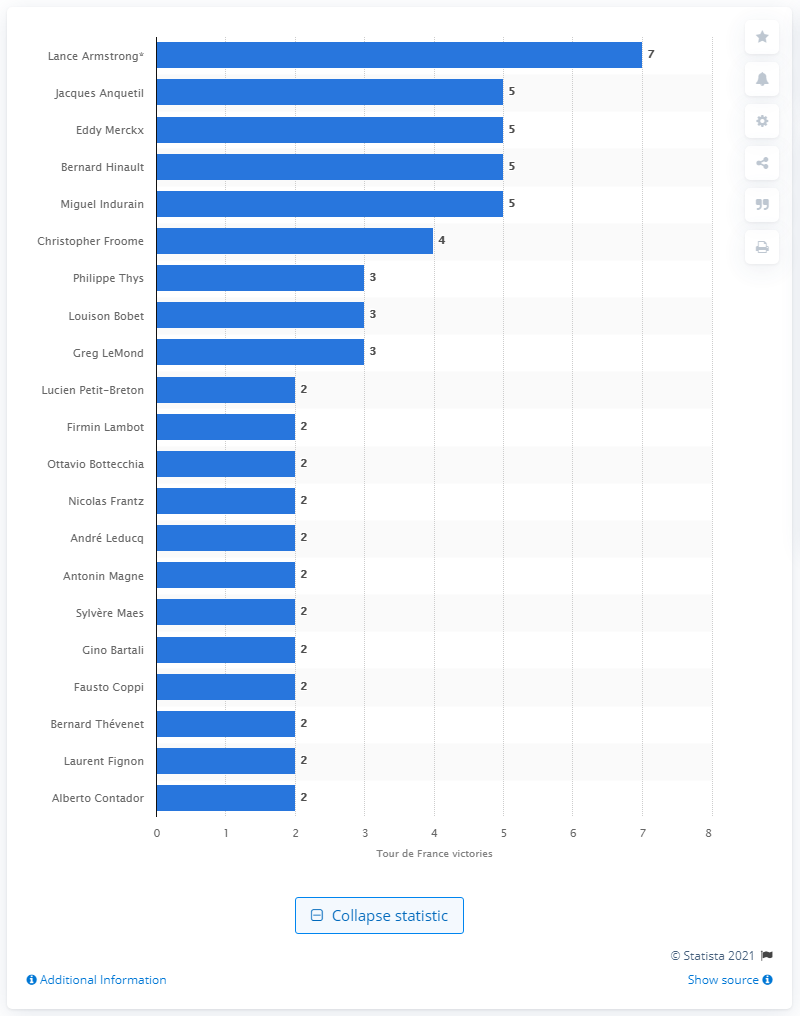Specify some key components in this picture. Greg LeMond has won the Tour de France three times. 